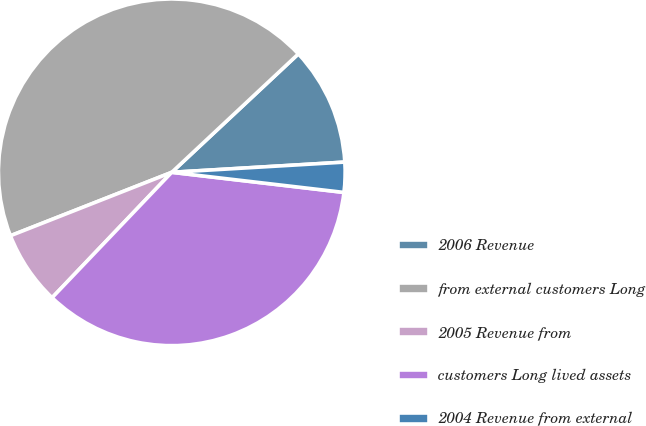Convert chart. <chart><loc_0><loc_0><loc_500><loc_500><pie_chart><fcel>2006 Revenue<fcel>from external customers Long<fcel>2005 Revenue from<fcel>customers Long lived assets<fcel>2004 Revenue from external<nl><fcel>11.03%<fcel>44.0%<fcel>6.91%<fcel>35.28%<fcel>2.79%<nl></chart> 